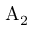Convert formula to latex. <formula><loc_0><loc_0><loc_500><loc_500>A _ { 2 }</formula> 